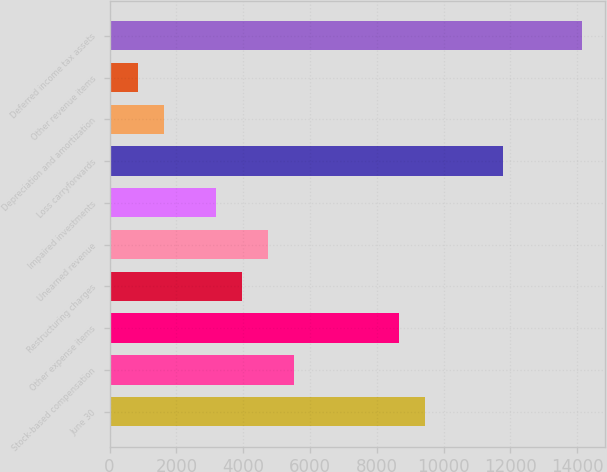Convert chart. <chart><loc_0><loc_0><loc_500><loc_500><bar_chart><fcel>June 30<fcel>Stock-based compensation<fcel>Other expense items<fcel>Restructuring charges<fcel>Unearned revenue<fcel>Impaired investments<fcel>Loss carryforwards<fcel>Depreciation and amortization<fcel>Other revenue items<fcel>Deferred income tax assets<nl><fcel>9442.8<fcel>5530.8<fcel>8660.4<fcel>3966<fcel>4748.4<fcel>3183.6<fcel>11790<fcel>1618.8<fcel>836.4<fcel>14137.2<nl></chart> 